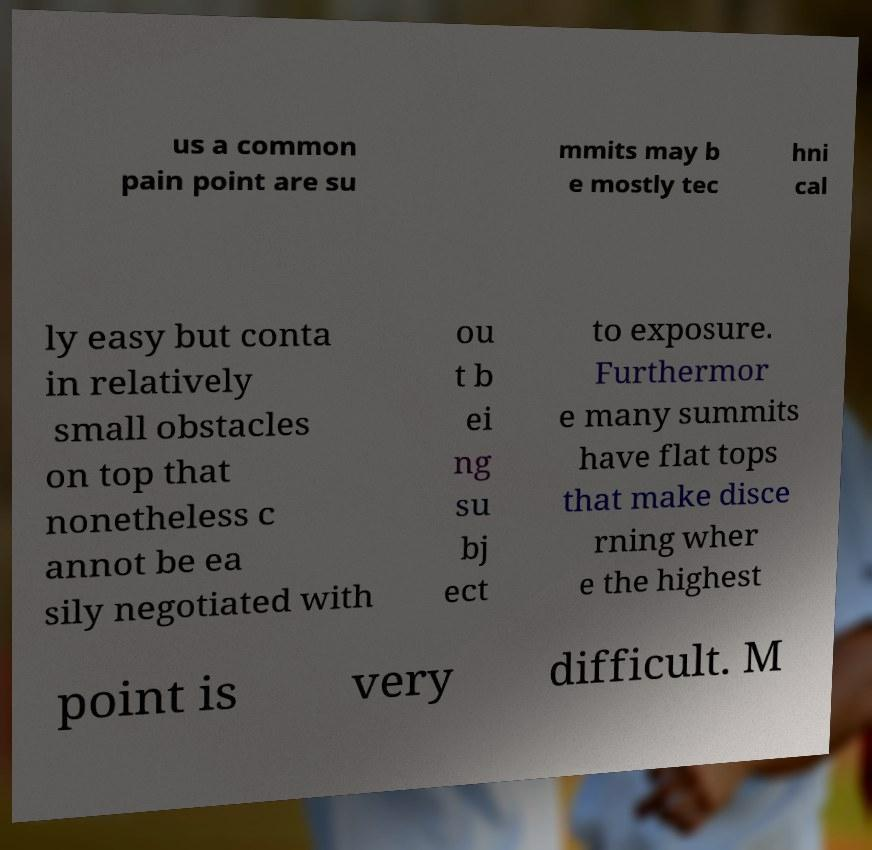Can you accurately transcribe the text from the provided image for me? us a common pain point are su mmits may b e mostly tec hni cal ly easy but conta in relatively small obstacles on top that nonetheless c annot be ea sily negotiated with ou t b ei ng su bj ect to exposure. Furthermor e many summits have flat tops that make disce rning wher e the highest point is very difficult. M 